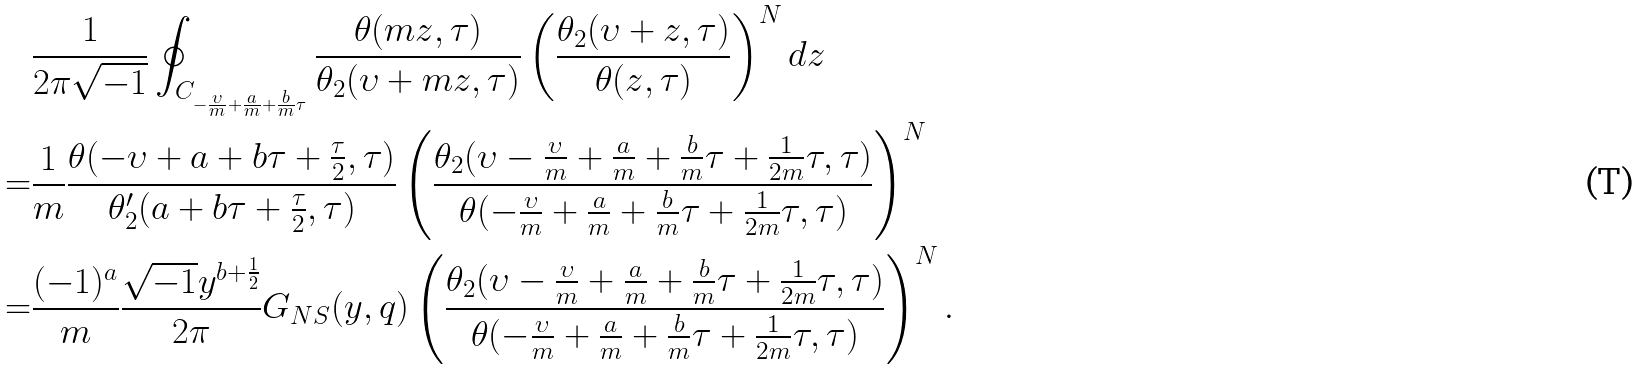<formula> <loc_0><loc_0><loc_500><loc_500>& \frac { 1 } { 2 \pi \sqrt { - 1 } } \oint _ { C _ { - \frac { \upsilon } { m } + \frac { a } { m } + \frac { b } { m } \tau } } \frac { \theta ( m z , \tau ) } { \theta _ { 2 } ( \upsilon + m z , \tau ) } \left ( \frac { \theta _ { 2 } ( \upsilon + z , \tau ) } { \theta ( z , \tau ) } \right ) ^ { N } d z \\ = & \frac { 1 } { m } \frac { \theta ( - \upsilon + a + b \tau + \frac { \tau } { 2 } , \tau ) } { \theta _ { 2 } ^ { \prime } ( a + b \tau + \frac { \tau } { 2 } , \tau ) } \left ( \frac { \theta _ { 2 } ( \upsilon - \frac { \upsilon } { m } + \frac { a } { m } + \frac { b } { m } \tau + \frac { 1 } { 2 m } \tau , \tau ) } { \theta ( - \frac { \upsilon } { m } + \frac { a } { m } + \frac { b } { m } \tau + \frac { 1 } { 2 m } \tau , \tau ) } \right ) ^ { N } \\ = & \frac { ( - 1 ) ^ { a } } { m } \frac { \sqrt { - 1 } y ^ { b + \frac { 1 } { 2 } } } { 2 \pi } G _ { N S } ( y , q ) \left ( \frac { \theta _ { 2 } ( \upsilon - \frac { \upsilon } { m } + \frac { a } { m } + \frac { b } { m } \tau + \frac { 1 } { 2 m } \tau , \tau ) } { \theta ( - \frac { \upsilon } { m } + \frac { a } { m } + \frac { b } { m } \tau + \frac { 1 } { 2 m } \tau , \tau ) } \right ) ^ { N } .</formula> 